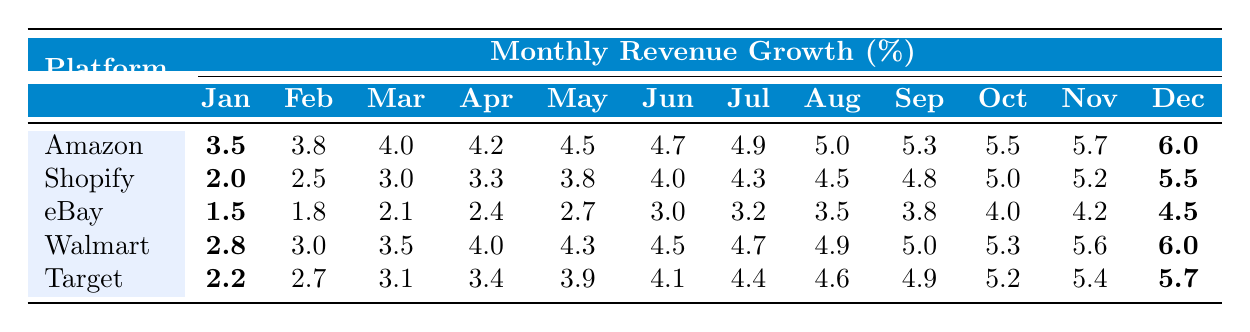What was the revenue growth percentage for Amazon in December? The table shows that the December revenue growth percentage for Amazon is bolded and listed as 6.0%.
Answer: 6.0% Which platform had the highest revenue growth in October? In the table, the October revenue growth percentages for each platform are listed. The highest value is 5.7% for Amazon.
Answer: Amazon What is the average monthly revenue growth for eBay over the year? To find the average for eBay, sum the monthly values (1.5 + 1.8 + 2.1 + 2.4 + 2.7 + 3.0 + 3.2 + 3.5 + 3.8 + 4.0 + 4.2 + 4.5 = 38.5) and divide by the number of months (12). So, 38.5 / 12 = 3.2083, approximately 3.21% when rounded.
Answer: 3.21% Did Target's revenue growth ever exceed 4.5% in the first half of the year? We check the percentages from January to June for Target: 2.2%, 2.7%, 3.1%, 3.4%, 3.9%, and 4.1%. None of these values exceed 4.5%.
Answer: No What is the difference in revenue growth between Amazon and Walmart in July? The revenue growth for Amazon in July is 4.9% and for Walmart is 4.7%. The difference is calculated as 4.9 - 4.7 = 0.2%.
Answer: 0.2% Which platform had the lowest revenue growth in January, and what was that percentage? The table indicates that eBay had the lowest revenue growth in January at 1.5%.
Answer: eBay, 1.5% Identify the platform with the consistent monthly growth rate between February and October that is closest to 4.5% on average. For each platform, we look at the values from February to October, calculate the average and find that Walmart has an average closest to 4.5% during those months: (3.0 + 3.5 + 4.0 + 4.3 + 4.5 + 4.7 + 4.9 + 5.0 + 5.3) / 9 = 4.3%.
Answer: Walmart What percentage increase does Shopify show from January to December? Shopify's growth in January is 2.0% and in December it is 5.5%. The increase is calculated as 5.5 - 2.0 = 3.5%.
Answer: 3.5% In which month did eBay first exceed a 3% revenue growth percentage? Looking at eBay's monthly growth percentages, eBay first exceeds 3% in June (3.0% is the last month not over 3%).
Answer: June Which platforms maintained a revenue growth of at least 5% from June to December? From June onwards, Amazon, Walmart, and Target consistently show growth rates at or above 5% till December.
Answer: Amazon, Walmart, Target 